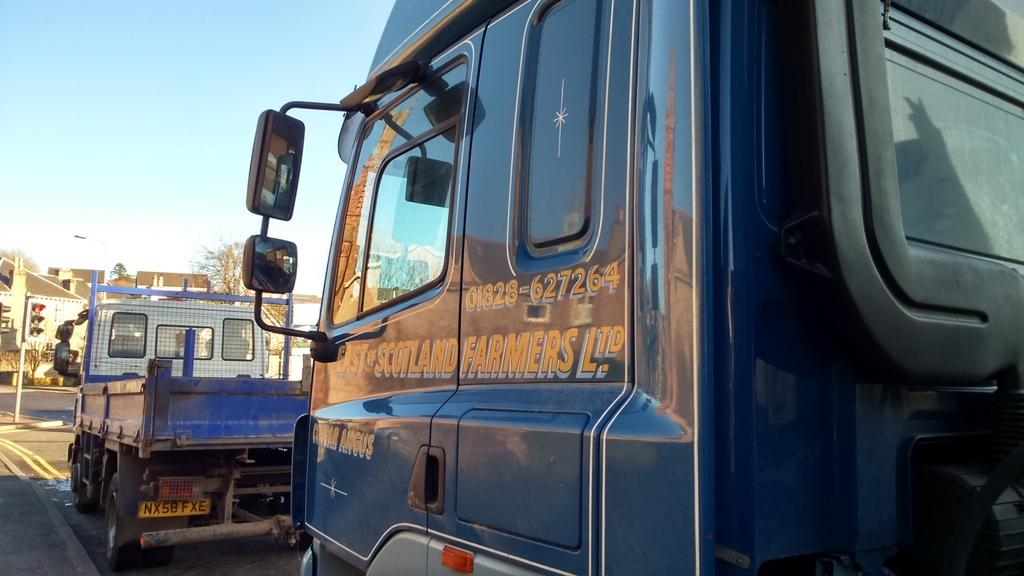What types of vehicles can be seen in the image? There are vehicles in the image, but the specific types are not mentioned. What is used to control traffic in the image? There is a traffic signal in the image. What structure is present in the image? There is a building in the image. What type of vegetation is visible in the image? There are trees in the image. What part of the natural environment is visible in the image? The sky is visible in the image. What type of lamp is hanging from the tree in the image? There is no lamp hanging from a tree in the image; there are only vehicles, a traffic signal, a building, trees, and the sky visible. What color is the cherry on the canvas in the image? There is no canvas or cherry present in the image. 